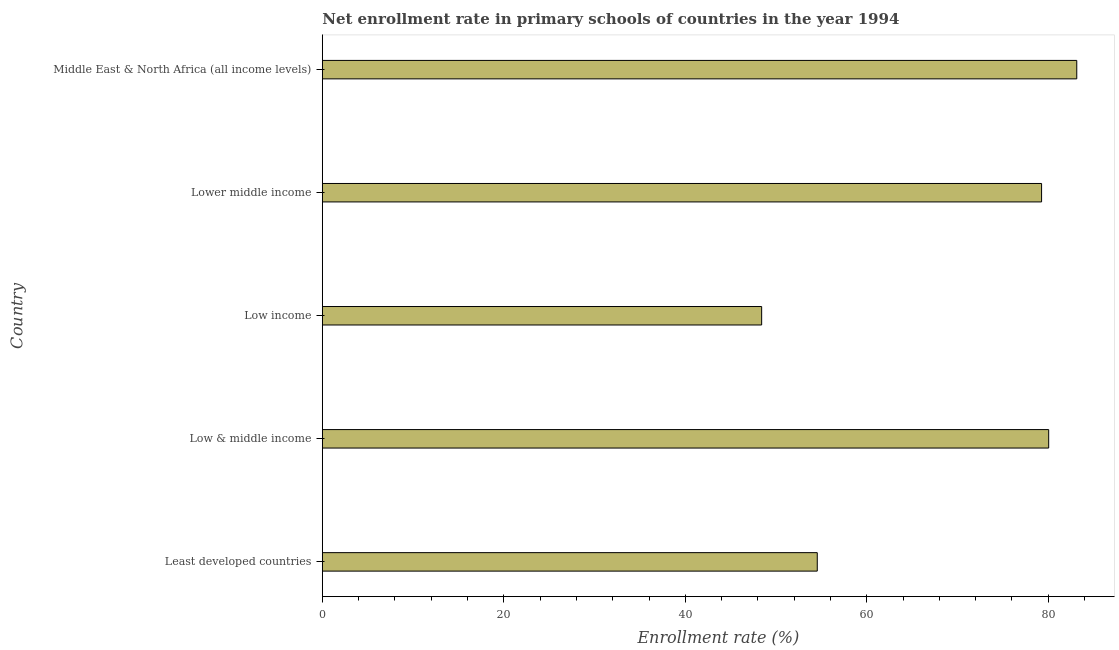Does the graph contain grids?
Offer a terse response. No. What is the title of the graph?
Your answer should be very brief. Net enrollment rate in primary schools of countries in the year 1994. What is the label or title of the X-axis?
Your response must be concise. Enrollment rate (%). What is the net enrollment rate in primary schools in Least developed countries?
Keep it short and to the point. 54.54. Across all countries, what is the maximum net enrollment rate in primary schools?
Give a very brief answer. 83.14. Across all countries, what is the minimum net enrollment rate in primary schools?
Offer a very short reply. 48.42. In which country was the net enrollment rate in primary schools maximum?
Give a very brief answer. Middle East & North Africa (all income levels). What is the sum of the net enrollment rate in primary schools?
Provide a succinct answer. 345.41. What is the difference between the net enrollment rate in primary schools in Low & middle income and Low income?
Ensure brevity in your answer.  31.63. What is the average net enrollment rate in primary schools per country?
Your answer should be compact. 69.08. What is the median net enrollment rate in primary schools?
Keep it short and to the point. 79.26. In how many countries, is the net enrollment rate in primary schools greater than 80 %?
Make the answer very short. 2. What is the ratio of the net enrollment rate in primary schools in Lower middle income to that in Middle East & North Africa (all income levels)?
Your answer should be compact. 0.95. Is the net enrollment rate in primary schools in Least developed countries less than that in Middle East & North Africa (all income levels)?
Make the answer very short. Yes. What is the difference between the highest and the second highest net enrollment rate in primary schools?
Make the answer very short. 3.09. Is the sum of the net enrollment rate in primary schools in Low income and Lower middle income greater than the maximum net enrollment rate in primary schools across all countries?
Provide a succinct answer. Yes. What is the difference between the highest and the lowest net enrollment rate in primary schools?
Provide a succinct answer. 34.73. In how many countries, is the net enrollment rate in primary schools greater than the average net enrollment rate in primary schools taken over all countries?
Offer a terse response. 3. How many bars are there?
Your response must be concise. 5. Are all the bars in the graph horizontal?
Keep it short and to the point. Yes. How many countries are there in the graph?
Provide a short and direct response. 5. What is the difference between two consecutive major ticks on the X-axis?
Make the answer very short. 20. What is the Enrollment rate (%) of Least developed countries?
Keep it short and to the point. 54.54. What is the Enrollment rate (%) in Low & middle income?
Ensure brevity in your answer.  80.05. What is the Enrollment rate (%) of Low income?
Offer a very short reply. 48.42. What is the Enrollment rate (%) in Lower middle income?
Provide a short and direct response. 79.26. What is the Enrollment rate (%) in Middle East & North Africa (all income levels)?
Keep it short and to the point. 83.14. What is the difference between the Enrollment rate (%) in Least developed countries and Low & middle income?
Your response must be concise. -25.5. What is the difference between the Enrollment rate (%) in Least developed countries and Low income?
Make the answer very short. 6.13. What is the difference between the Enrollment rate (%) in Least developed countries and Lower middle income?
Your answer should be very brief. -24.72. What is the difference between the Enrollment rate (%) in Least developed countries and Middle East & North Africa (all income levels)?
Your response must be concise. -28.6. What is the difference between the Enrollment rate (%) in Low & middle income and Low income?
Provide a short and direct response. 31.63. What is the difference between the Enrollment rate (%) in Low & middle income and Lower middle income?
Offer a terse response. 0.78. What is the difference between the Enrollment rate (%) in Low & middle income and Middle East & North Africa (all income levels)?
Provide a succinct answer. -3.09. What is the difference between the Enrollment rate (%) in Low income and Lower middle income?
Offer a very short reply. -30.85. What is the difference between the Enrollment rate (%) in Low income and Middle East & North Africa (all income levels)?
Your answer should be very brief. -34.73. What is the difference between the Enrollment rate (%) in Lower middle income and Middle East & North Africa (all income levels)?
Offer a very short reply. -3.88. What is the ratio of the Enrollment rate (%) in Least developed countries to that in Low & middle income?
Ensure brevity in your answer.  0.68. What is the ratio of the Enrollment rate (%) in Least developed countries to that in Low income?
Give a very brief answer. 1.13. What is the ratio of the Enrollment rate (%) in Least developed countries to that in Lower middle income?
Provide a short and direct response. 0.69. What is the ratio of the Enrollment rate (%) in Least developed countries to that in Middle East & North Africa (all income levels)?
Make the answer very short. 0.66. What is the ratio of the Enrollment rate (%) in Low & middle income to that in Low income?
Give a very brief answer. 1.65. What is the ratio of the Enrollment rate (%) in Low income to that in Lower middle income?
Make the answer very short. 0.61. What is the ratio of the Enrollment rate (%) in Low income to that in Middle East & North Africa (all income levels)?
Provide a succinct answer. 0.58. What is the ratio of the Enrollment rate (%) in Lower middle income to that in Middle East & North Africa (all income levels)?
Offer a terse response. 0.95. 